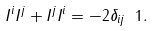<formula> <loc_0><loc_0><loc_500><loc_500>I ^ { i } I ^ { j } + I ^ { j } I ^ { i } = - 2 \delta _ { i j } \ 1 .</formula> 